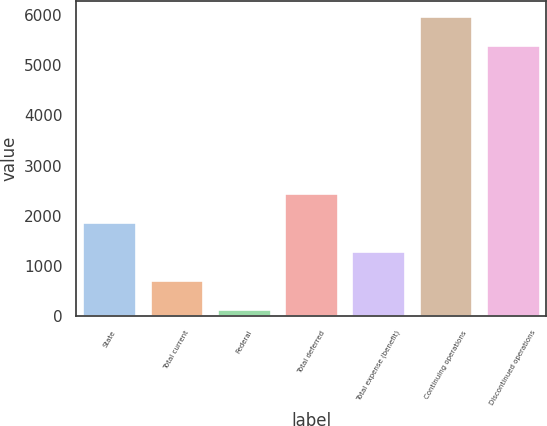<chart> <loc_0><loc_0><loc_500><loc_500><bar_chart><fcel>State<fcel>Total current<fcel>Federal<fcel>Total deferred<fcel>Total expense (benefit)<fcel>Continuing operations<fcel>Discontinued operations<nl><fcel>1882.4<fcel>722.8<fcel>143<fcel>2462.2<fcel>1302.6<fcel>5969.8<fcel>5390<nl></chart> 